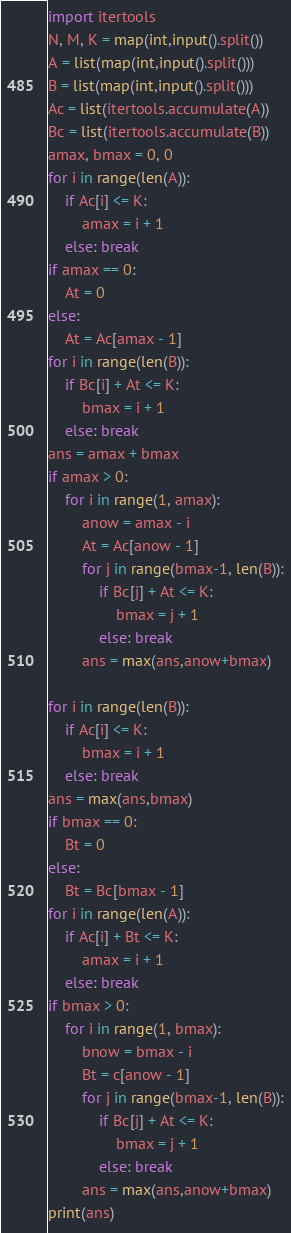<code> <loc_0><loc_0><loc_500><loc_500><_Python_>import itertools
N, M, K = map(int,input().split())
A = list(map(int,input().split()))
B = list(map(int,input().split()))
Ac = list(itertools.accumulate(A))
Bc = list(itertools.accumulate(B))
amax, bmax = 0, 0
for i in range(len(A)):
    if Ac[i] <= K:
        amax = i + 1
    else: break
if amax == 0:
    At = 0
else:
    At = Ac[amax - 1]
for i in range(len(B)):
    if Bc[i] + At <= K:
        bmax = i + 1
    else: break
ans = amax + bmax
if amax > 0:
    for i in range(1, amax):
        anow = amax - i
        At = Ac[anow - 1]
        for j in range(bmax-1, len(B)):
            if Bc[j] + At <= K:
                bmax = j + 1
            else: break
        ans = max(ans,anow+bmax)
        
for i in range(len(B)):
    if Ac[i] <= K:
        bmax = i + 1
    else: break
ans = max(ans,bmax)
if bmax == 0:
    Bt = 0
else:
    Bt = Bc[bmax - 1]
for i in range(len(A)):
    if Ac[i] + Bt <= K:
        amax = i + 1
    else: break
if bmax > 0:
    for i in range(1, bmax):
        bnow = bmax - i
        Bt = c[anow - 1]
        for j in range(bmax-1, len(B)):
            if Bc[j] + At <= K:
                bmax = j + 1
            else: break
        ans = max(ans,anow+bmax)
print(ans)</code> 